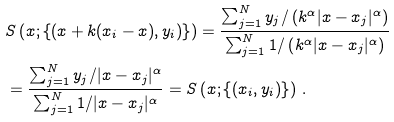Convert formula to latex. <formula><loc_0><loc_0><loc_500><loc_500>& S \left ( x ; \left \{ \left ( x + k ( x _ { i } - x ) , y _ { i } \right ) \right \} \right ) = \frac { \sum _ { j = 1 } ^ { N } y _ { j } / \left ( k ^ { \alpha } | x - x _ { j } | ^ { \alpha } \right ) } { \sum _ { j = 1 } ^ { N } 1 / \left ( k ^ { \alpha } | x - x _ { j } | ^ { \alpha } \right ) } \\ & = \frac { \sum _ { j = 1 } ^ { N } y _ { j } / | x - x _ { j } | ^ { \alpha } } { \sum _ { j = 1 } ^ { N } 1 / | x - x _ { j } | ^ { \alpha } } = S \left ( x ; \left \{ ( x _ { i } , y _ { i } ) \right \} \right ) \, .</formula> 